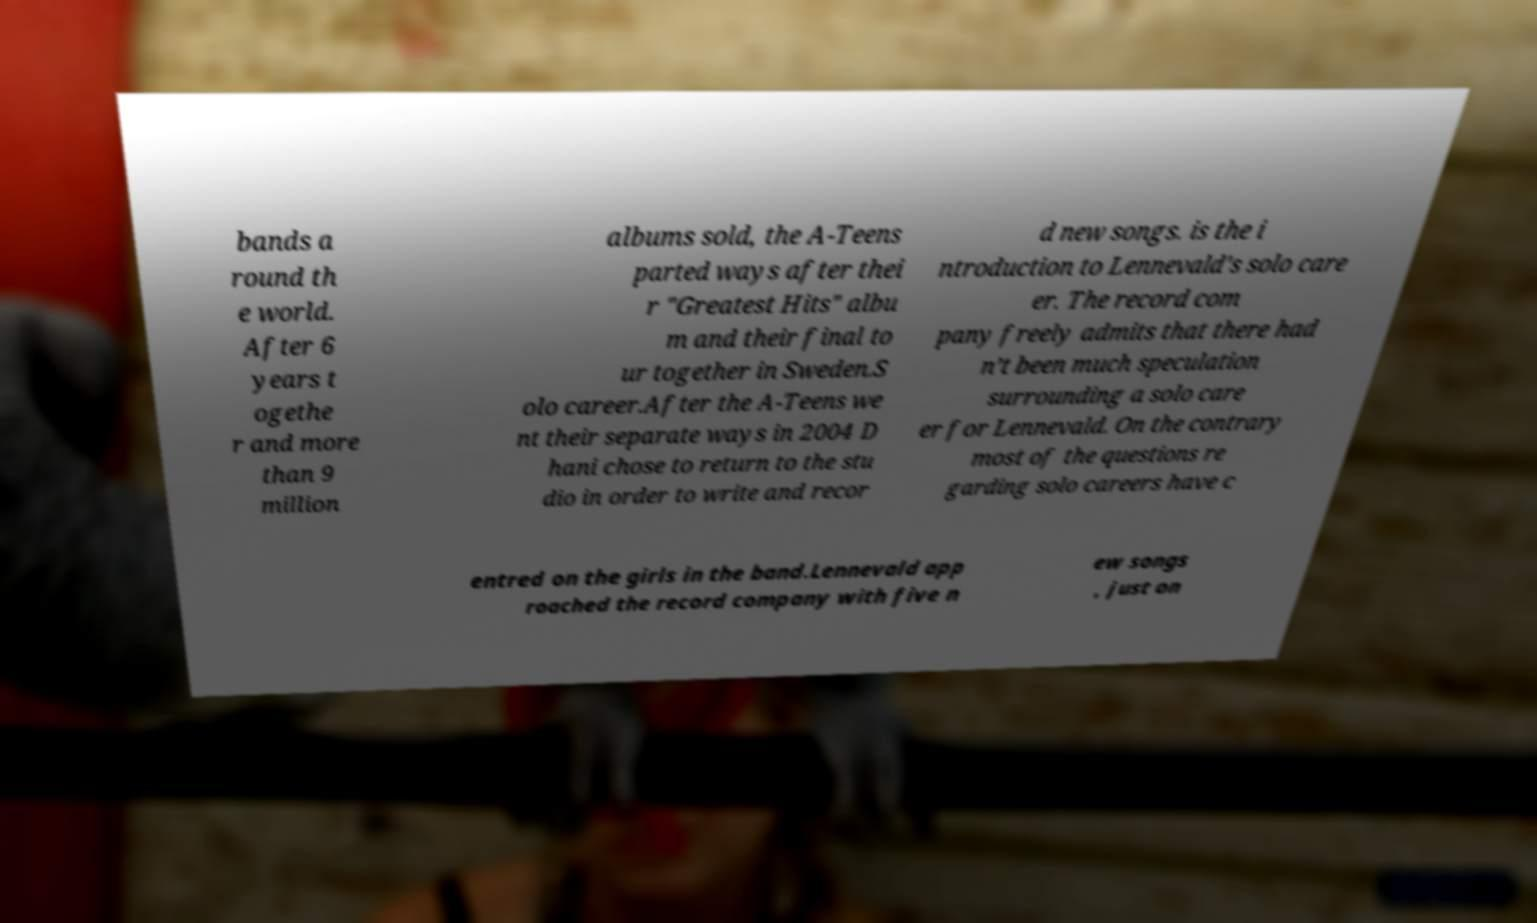Could you assist in decoding the text presented in this image and type it out clearly? bands a round th e world. After 6 years t ogethe r and more than 9 million albums sold, the A-Teens parted ways after thei r "Greatest Hits" albu m and their final to ur together in Sweden.S olo career.After the A-Teens we nt their separate ways in 2004 D hani chose to return to the stu dio in order to write and recor d new songs. is the i ntroduction to Lennevald's solo care er. The record com pany freely admits that there had n’t been much speculation surrounding a solo care er for Lennevald. On the contrary most of the questions re garding solo careers have c entred on the girls in the band.Lennevald app roached the record company with five n ew songs , just on 